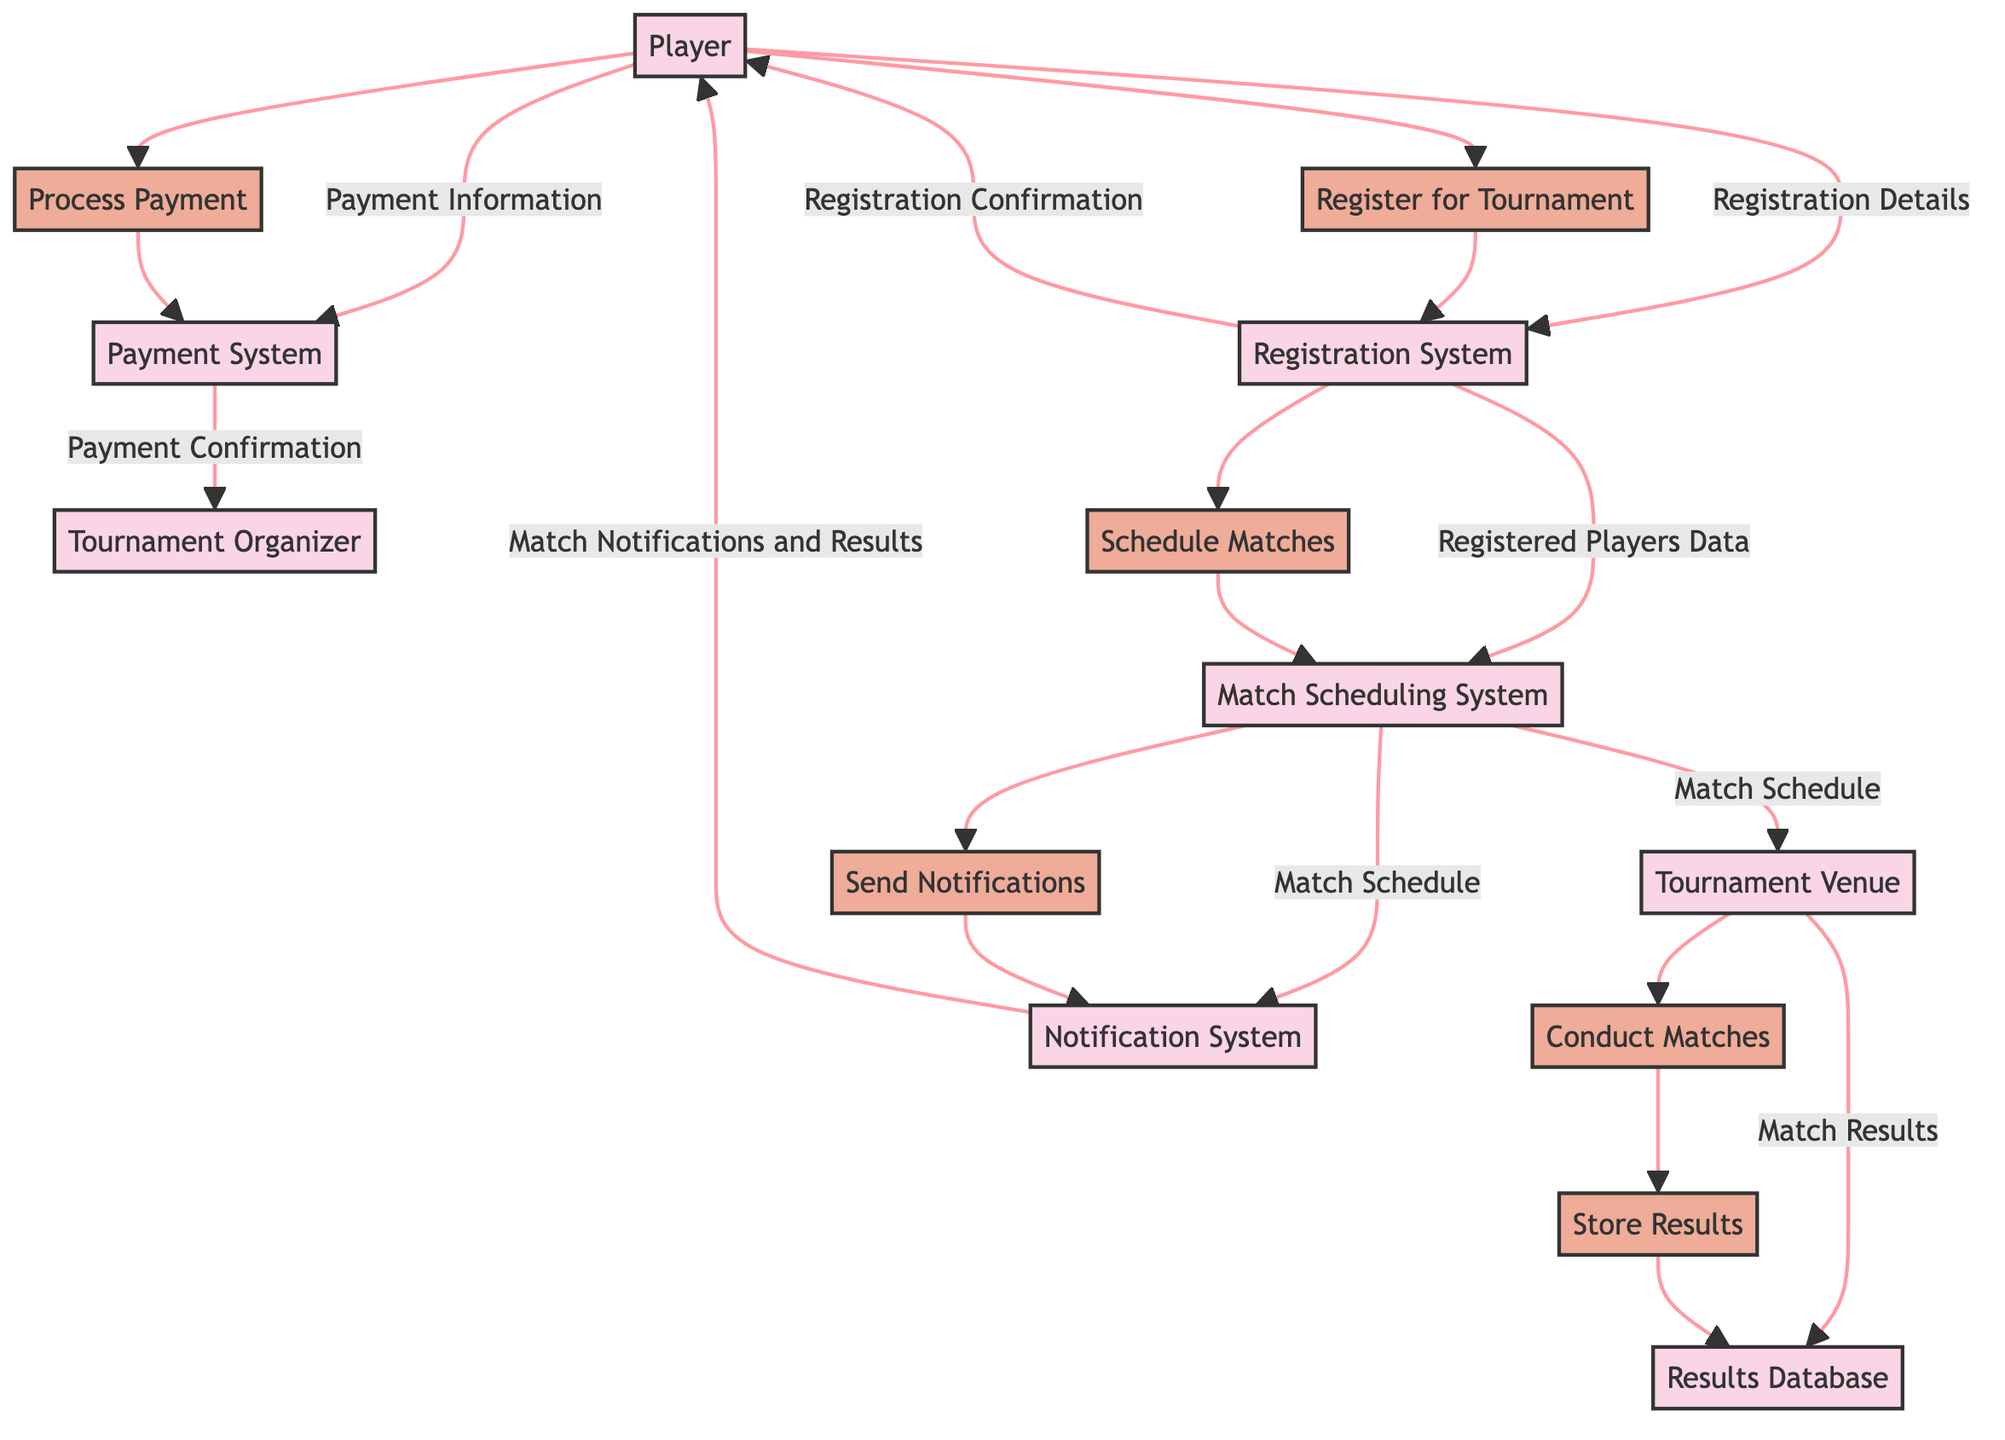What's the total number of entities in the diagram? The diagram lists eight unique entities, which include the Player, Tournament Organizer, Registration System, Payment System, Match Scheduling System, Tournament Venue, Results Database, and Notification System.
Answer: 8 What data flows from the Player to the Registration System? The data flow from the Player to the Registration System is "Registration Details". This is indicated in the diagram as the arrow shows that the Player sends their registration information to the Registration System.
Answer: Registration Details What process comes after the Player registers for the tournament? After the Player registers, the next step involves processing payment. This is indicated by the arrows leading from the Player to the Payment System, showing that payment information is provided after registration.
Answer: Process Payment What does the Match Scheduling System send to the Notification System? The Match Scheduling System sends the "Match Schedule" to the Notification System. In the diagram, this is shown as a flow from the Match Scheduling System to the Notification System.
Answer: Match Schedule What is the data that flows from the Tournament Venue to the Results Database? The data that flows from the Tournament Venue to the Results Database is "Match Results". This is illustrated in the diagram as the Tournament Venue produces match results that are then stored in the Results Database.
Answer: Match Results What is the purpose of the Notification System in the tournament logistics? The Notification System's purpose is to send match notifications and results to the players. This is clearly conveyed in the diagram through the flow of data from the Notification System to the Player.
Answer: Send notifications Which two entities are responsible for processing payments? The two entities responsible for processing payments are the Payment System and the Tournament Organizer. The Payment System processes payment information, and the Tournament Organizer receives payment confirmations from the Payment System.
Answer: Payment System and Tournament Organizer How many processes are related to match management from scheduling to results? There are three processes specifically related to match management: Schedule Matches, Conduct Matches, and Store Results. These processes flow logically in the progression from scheduling to conducting and then storing the results of the matches.
Answer: 3 What is the first task a Player must complete according to the diagram? The first task a Player must complete is to register for the tournament, as indicated in the diagram which shows the initial step of the Player flowing into the Registration System.
Answer: Register for Tournament 